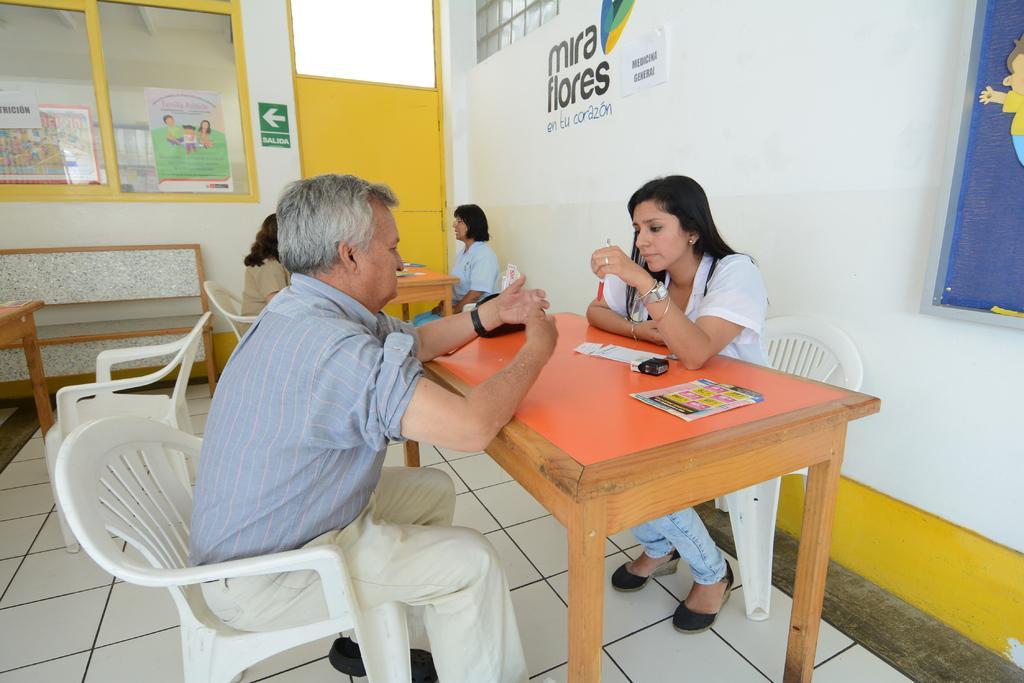Describe this image in one or two sentences. In this picture we have four people sitting per two on different tables and different chairs and on the table we have the papers and among them three are women and one is a man and there are some wall postures and on the other side there is a bench and a empty chair. 